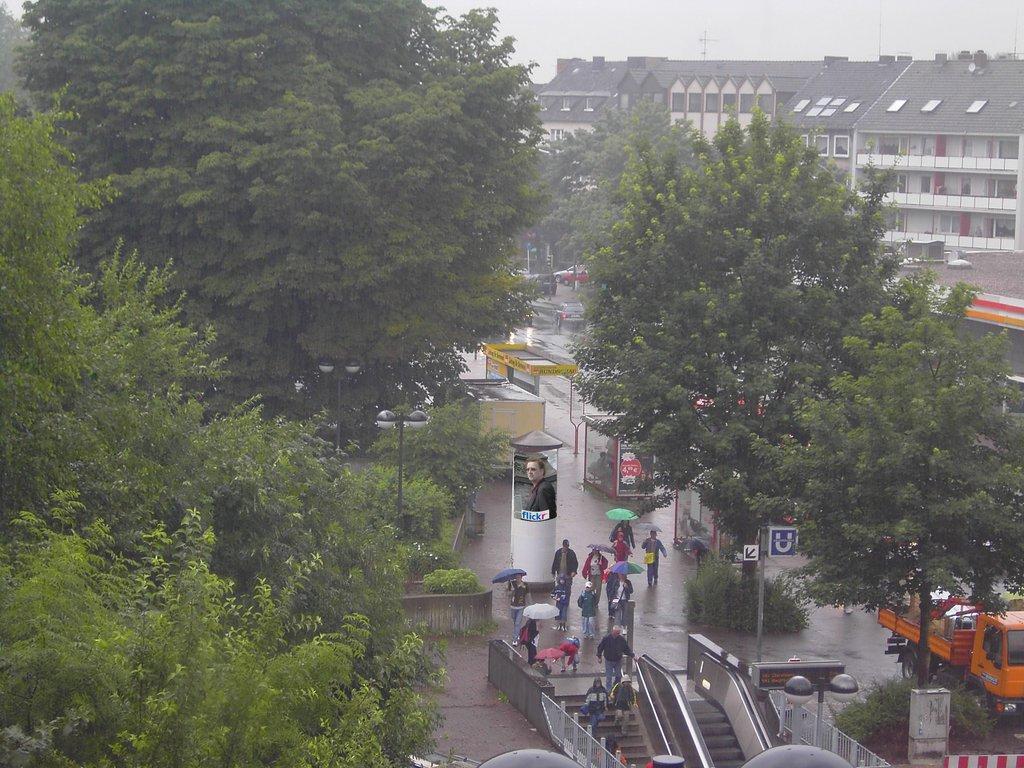Could you give a brief overview of what you see in this image? In this picture I can see few trees and buildings and a mini truck and few people walking holding umbrellas and I can see a pole light and a sign board to the pole and I can see stairs and few plants and I can see a cloudy sky and few cars. 